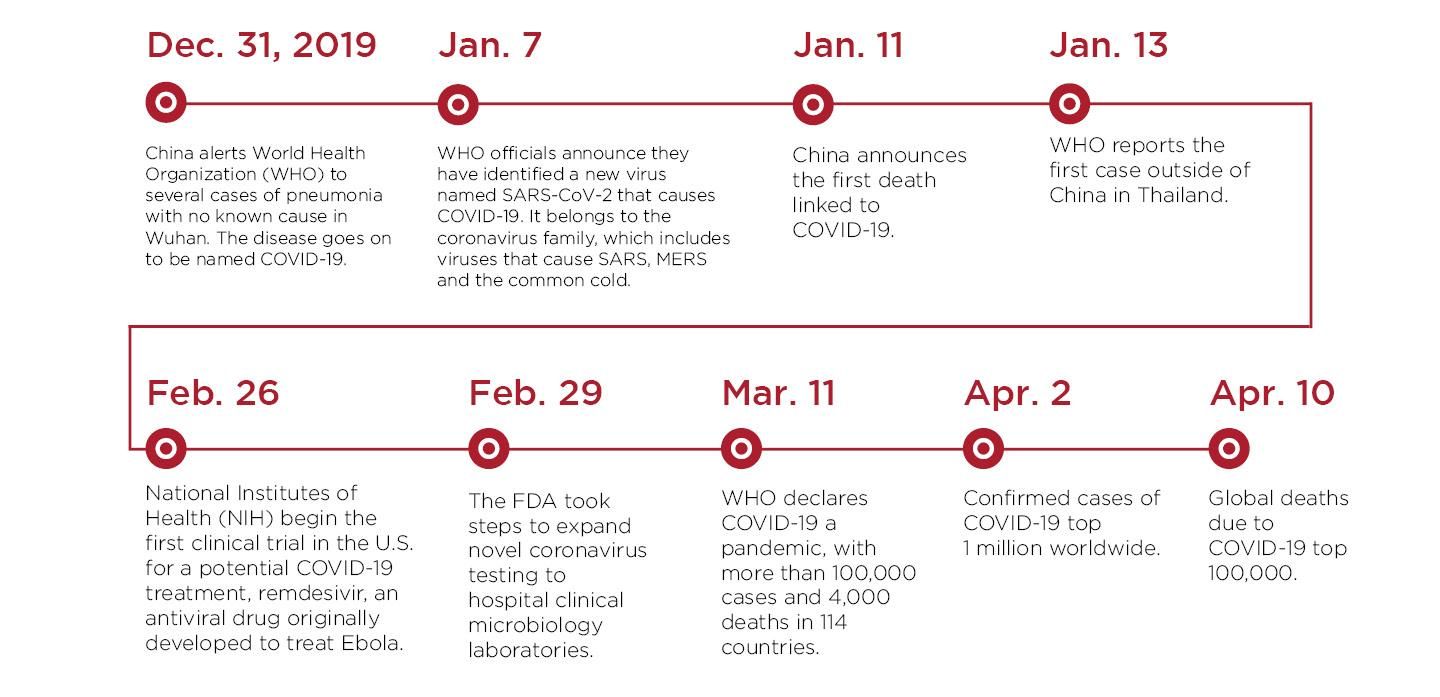Give some essential details in this illustration. The number of cases worldwide exceeded 1 million on April 2020. The first death attributed to COVID-19 was reported on January 11. The World Health Organization reported the first case of COVID-19 outside of China on January 13. 